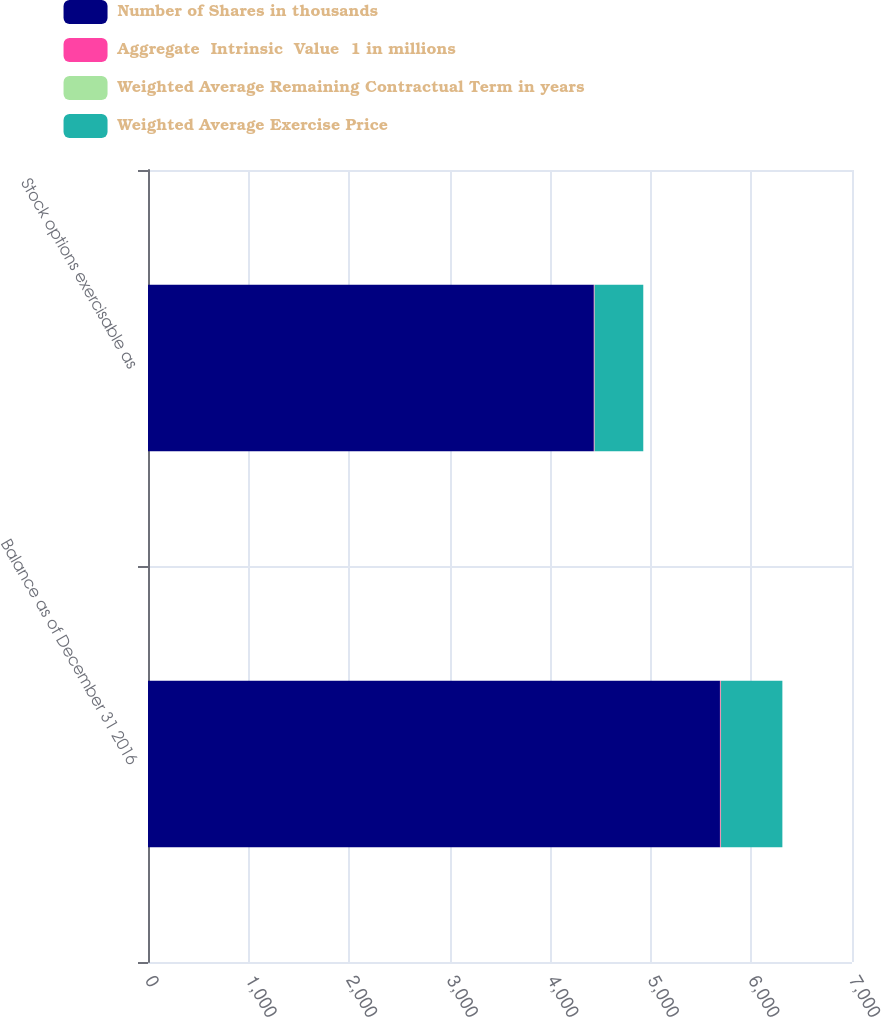<chart> <loc_0><loc_0><loc_500><loc_500><stacked_bar_chart><ecel><fcel>Balance as of December 31 2016<fcel>Stock options exercisable as<nl><fcel>Number of Shares in thousands<fcel>5687<fcel>4433<nl><fcel>Aggregate  Intrinsic  Value  1 in millions<fcel>7.78<fcel>6.05<nl><fcel>Weighted Average Remaining Contractual Term in years<fcel>2.9<fcel>2.6<nl><fcel>Weighted Average Exercise Price<fcel>610<fcel>483<nl></chart> 